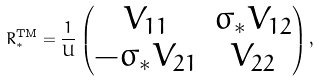<formula> <loc_0><loc_0><loc_500><loc_500>R _ { * } ^ { \text {TM} } = \frac { 1 } { U } \begin{pmatrix} V _ { 1 1 } & \sigma _ { * } V _ { 1 2 } \\ - \sigma _ { * } V _ { 2 1 } & V _ { 2 2 } \end{pmatrix} ,</formula> 